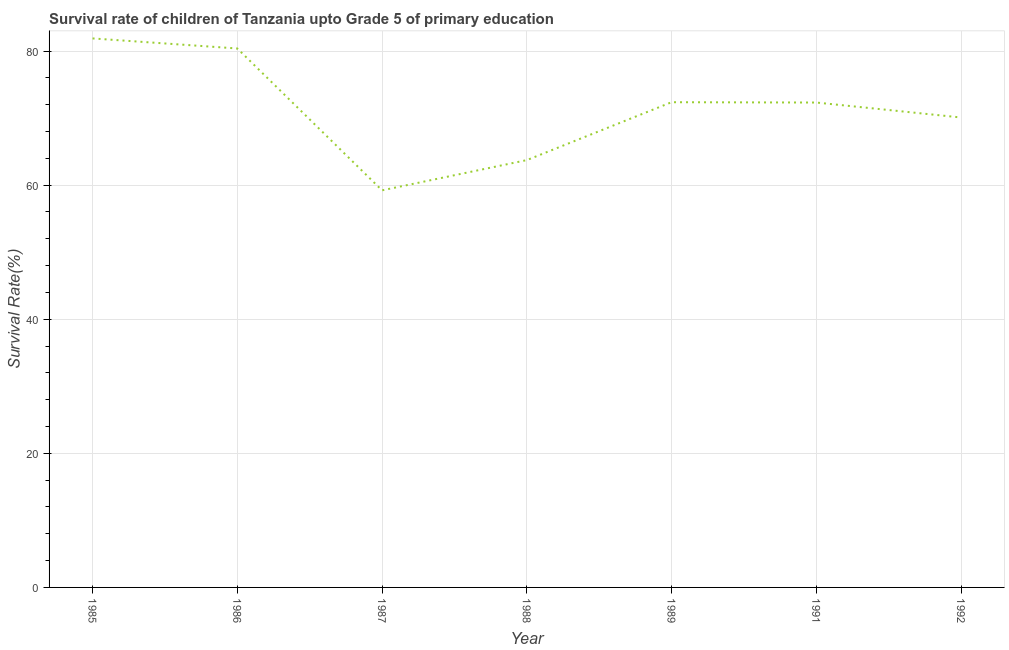What is the survival rate in 1991?
Make the answer very short. 72.32. Across all years, what is the maximum survival rate?
Offer a very short reply. 81.89. Across all years, what is the minimum survival rate?
Make the answer very short. 59.23. In which year was the survival rate minimum?
Give a very brief answer. 1987. What is the sum of the survival rate?
Offer a terse response. 500.02. What is the difference between the survival rate in 1991 and 1992?
Provide a short and direct response. 2.23. What is the average survival rate per year?
Your answer should be very brief. 71.43. What is the median survival rate?
Your answer should be very brief. 72.32. In how many years, is the survival rate greater than 36 %?
Your answer should be compact. 7. What is the ratio of the survival rate in 1986 to that in 1989?
Provide a short and direct response. 1.11. Is the difference between the survival rate in 1988 and 1989 greater than the difference between any two years?
Provide a short and direct response. No. What is the difference between the highest and the second highest survival rate?
Give a very brief answer. 1.5. Is the sum of the survival rate in 1991 and 1992 greater than the maximum survival rate across all years?
Offer a very short reply. Yes. What is the difference between the highest and the lowest survival rate?
Give a very brief answer. 22.66. How many lines are there?
Your answer should be compact. 1. Are the values on the major ticks of Y-axis written in scientific E-notation?
Offer a very short reply. No. Does the graph contain any zero values?
Make the answer very short. No. Does the graph contain grids?
Offer a very short reply. Yes. What is the title of the graph?
Keep it short and to the point. Survival rate of children of Tanzania upto Grade 5 of primary education. What is the label or title of the Y-axis?
Your answer should be compact. Survival Rate(%). What is the Survival Rate(%) of 1985?
Your answer should be very brief. 81.89. What is the Survival Rate(%) of 1986?
Keep it short and to the point. 80.39. What is the Survival Rate(%) in 1987?
Provide a succinct answer. 59.23. What is the Survival Rate(%) in 1988?
Offer a very short reply. 63.74. What is the Survival Rate(%) of 1989?
Offer a very short reply. 72.37. What is the Survival Rate(%) of 1991?
Ensure brevity in your answer.  72.32. What is the Survival Rate(%) in 1992?
Your answer should be compact. 70.09. What is the difference between the Survival Rate(%) in 1985 and 1986?
Offer a terse response. 1.5. What is the difference between the Survival Rate(%) in 1985 and 1987?
Provide a short and direct response. 22.66. What is the difference between the Survival Rate(%) in 1985 and 1988?
Your answer should be compact. 18.15. What is the difference between the Survival Rate(%) in 1985 and 1989?
Provide a short and direct response. 9.51. What is the difference between the Survival Rate(%) in 1985 and 1991?
Keep it short and to the point. 9.56. What is the difference between the Survival Rate(%) in 1985 and 1992?
Provide a succinct answer. 11.8. What is the difference between the Survival Rate(%) in 1986 and 1987?
Offer a terse response. 21.16. What is the difference between the Survival Rate(%) in 1986 and 1988?
Your response must be concise. 16.65. What is the difference between the Survival Rate(%) in 1986 and 1989?
Your response must be concise. 8.01. What is the difference between the Survival Rate(%) in 1986 and 1991?
Give a very brief answer. 8.06. What is the difference between the Survival Rate(%) in 1986 and 1992?
Keep it short and to the point. 10.29. What is the difference between the Survival Rate(%) in 1987 and 1988?
Offer a very short reply. -4.51. What is the difference between the Survival Rate(%) in 1987 and 1989?
Provide a succinct answer. -13.15. What is the difference between the Survival Rate(%) in 1987 and 1991?
Offer a very short reply. -13.1. What is the difference between the Survival Rate(%) in 1987 and 1992?
Offer a terse response. -10.86. What is the difference between the Survival Rate(%) in 1988 and 1989?
Offer a terse response. -8.64. What is the difference between the Survival Rate(%) in 1988 and 1991?
Keep it short and to the point. -8.59. What is the difference between the Survival Rate(%) in 1988 and 1992?
Keep it short and to the point. -6.36. What is the difference between the Survival Rate(%) in 1989 and 1991?
Give a very brief answer. 0.05. What is the difference between the Survival Rate(%) in 1989 and 1992?
Give a very brief answer. 2.28. What is the difference between the Survival Rate(%) in 1991 and 1992?
Your response must be concise. 2.23. What is the ratio of the Survival Rate(%) in 1985 to that in 1987?
Provide a short and direct response. 1.38. What is the ratio of the Survival Rate(%) in 1985 to that in 1988?
Offer a very short reply. 1.28. What is the ratio of the Survival Rate(%) in 1985 to that in 1989?
Give a very brief answer. 1.13. What is the ratio of the Survival Rate(%) in 1985 to that in 1991?
Provide a succinct answer. 1.13. What is the ratio of the Survival Rate(%) in 1985 to that in 1992?
Provide a short and direct response. 1.17. What is the ratio of the Survival Rate(%) in 1986 to that in 1987?
Your response must be concise. 1.36. What is the ratio of the Survival Rate(%) in 1986 to that in 1988?
Your answer should be compact. 1.26. What is the ratio of the Survival Rate(%) in 1986 to that in 1989?
Provide a short and direct response. 1.11. What is the ratio of the Survival Rate(%) in 1986 to that in 1991?
Make the answer very short. 1.11. What is the ratio of the Survival Rate(%) in 1986 to that in 1992?
Your response must be concise. 1.15. What is the ratio of the Survival Rate(%) in 1987 to that in 1988?
Ensure brevity in your answer.  0.93. What is the ratio of the Survival Rate(%) in 1987 to that in 1989?
Offer a very short reply. 0.82. What is the ratio of the Survival Rate(%) in 1987 to that in 1991?
Offer a terse response. 0.82. What is the ratio of the Survival Rate(%) in 1987 to that in 1992?
Provide a short and direct response. 0.84. What is the ratio of the Survival Rate(%) in 1988 to that in 1989?
Keep it short and to the point. 0.88. What is the ratio of the Survival Rate(%) in 1988 to that in 1991?
Keep it short and to the point. 0.88. What is the ratio of the Survival Rate(%) in 1988 to that in 1992?
Ensure brevity in your answer.  0.91. What is the ratio of the Survival Rate(%) in 1989 to that in 1991?
Make the answer very short. 1. What is the ratio of the Survival Rate(%) in 1989 to that in 1992?
Give a very brief answer. 1.03. What is the ratio of the Survival Rate(%) in 1991 to that in 1992?
Your answer should be compact. 1.03. 